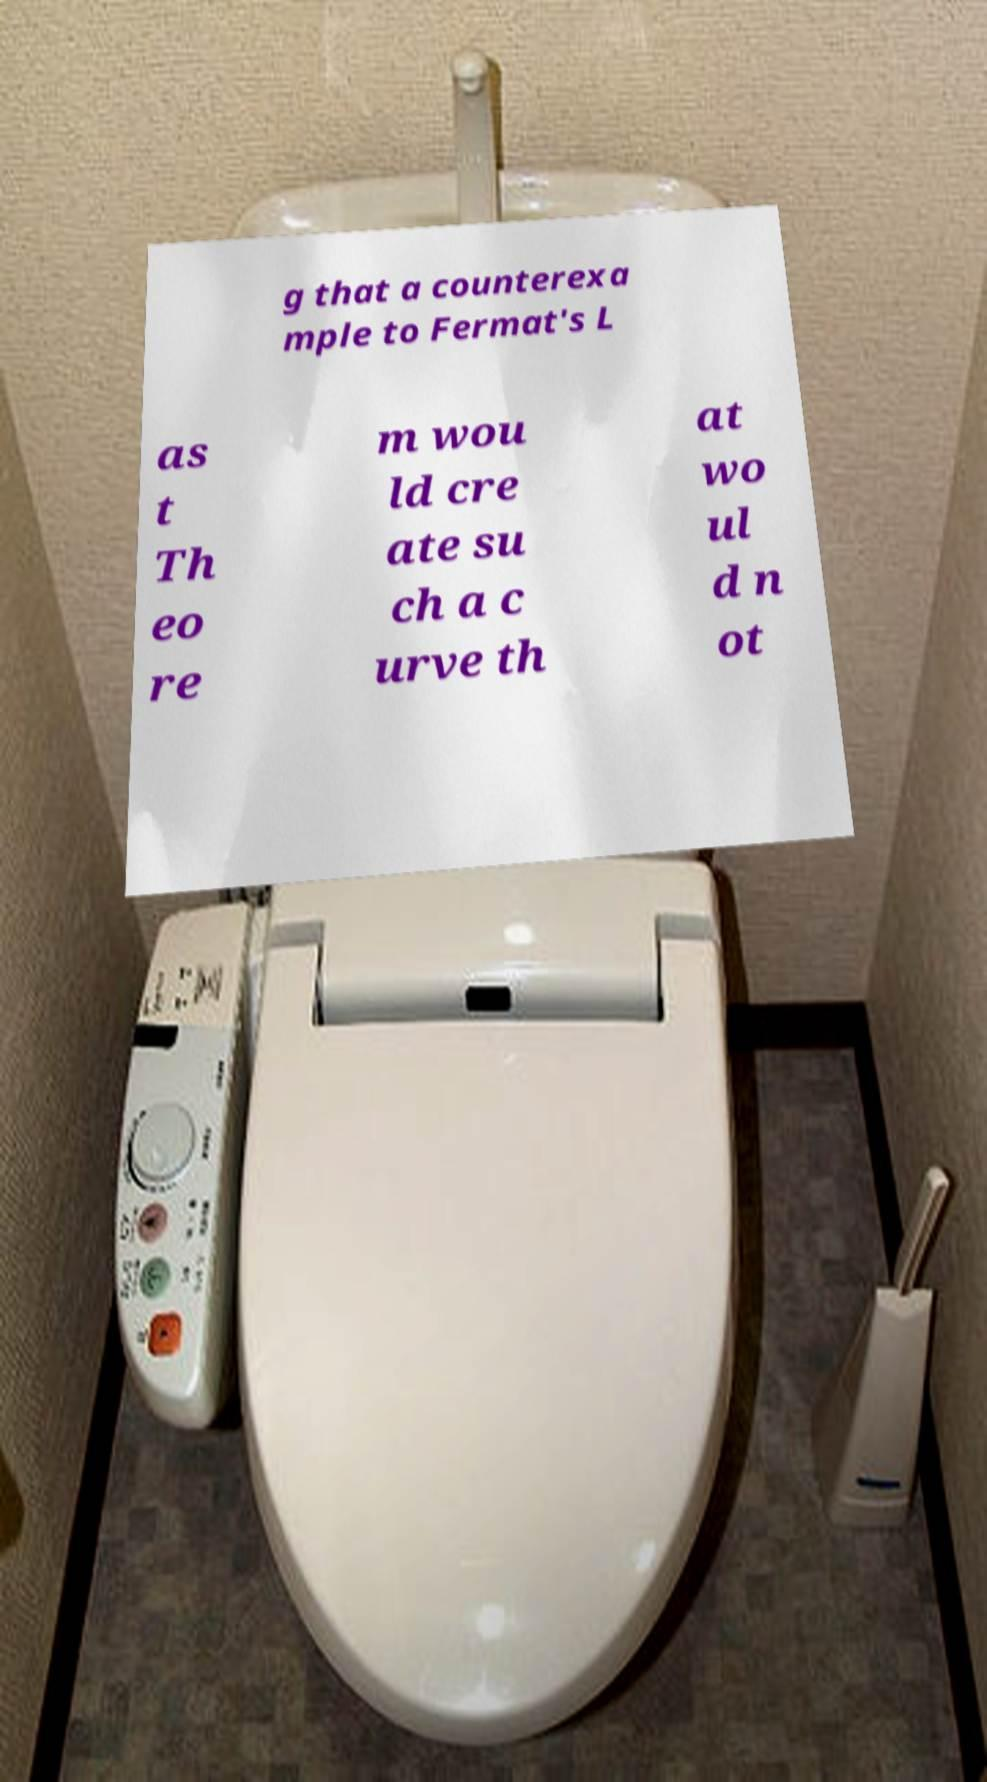Please identify and transcribe the text found in this image. g that a counterexa mple to Fermat's L as t Th eo re m wou ld cre ate su ch a c urve th at wo ul d n ot 